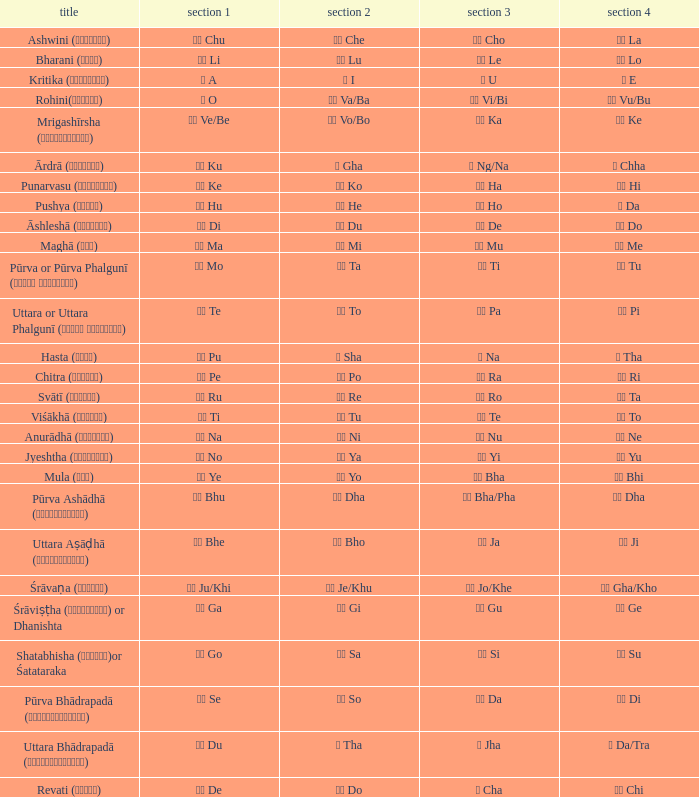What is the Name of ङ ng/na? Ārdrā (आर्द्रा). 